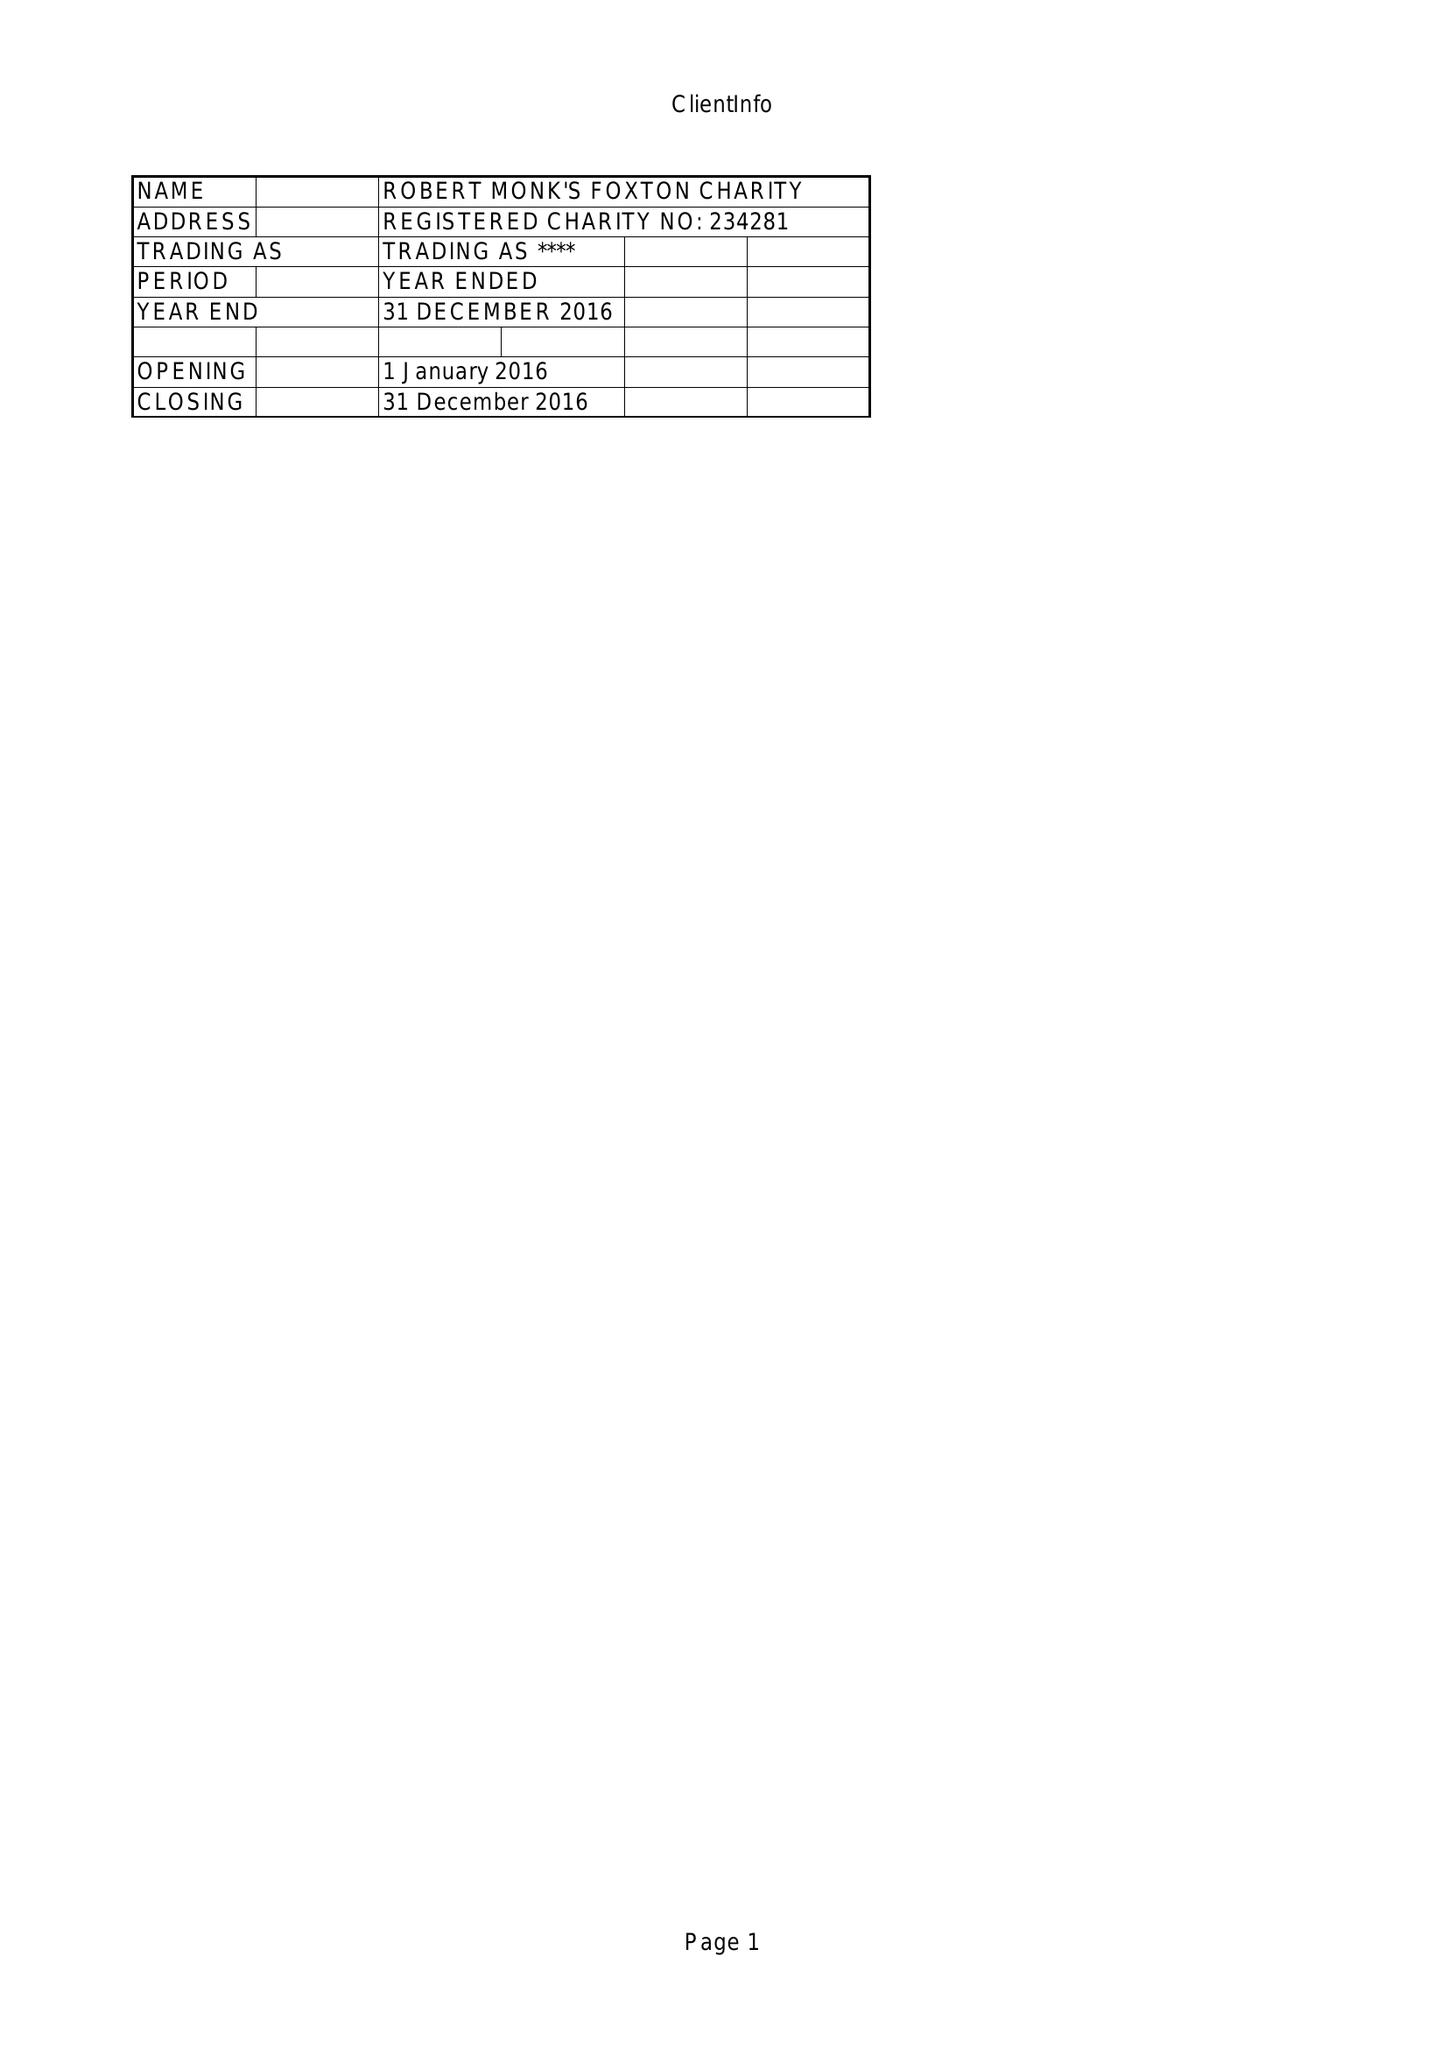What is the value for the charity_name?
Answer the question using a single word or phrase. Robert Monks Foxton Charity 